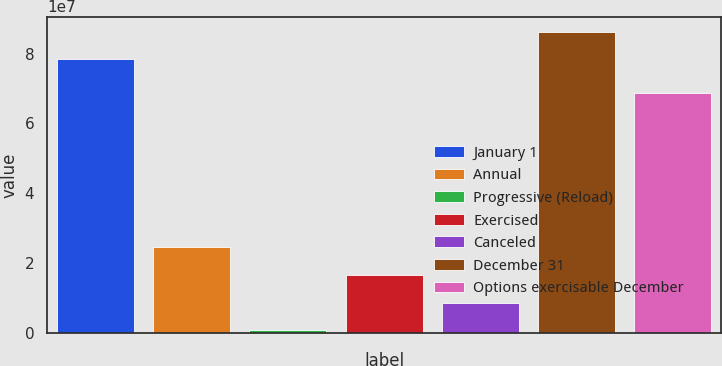Convert chart to OTSL. <chart><loc_0><loc_0><loc_500><loc_500><bar_chart><fcel>January 1<fcel>Annual<fcel>Progressive (Reload)<fcel>Exercised<fcel>Canceled<fcel>December 31<fcel>Options exercisable December<nl><fcel>7.82938e+07<fcel>2.45737e+07<fcel>751995<fcel>1.66331e+07<fcel>8.69257e+06<fcel>8.62343e+07<fcel>6.87142e+07<nl></chart> 